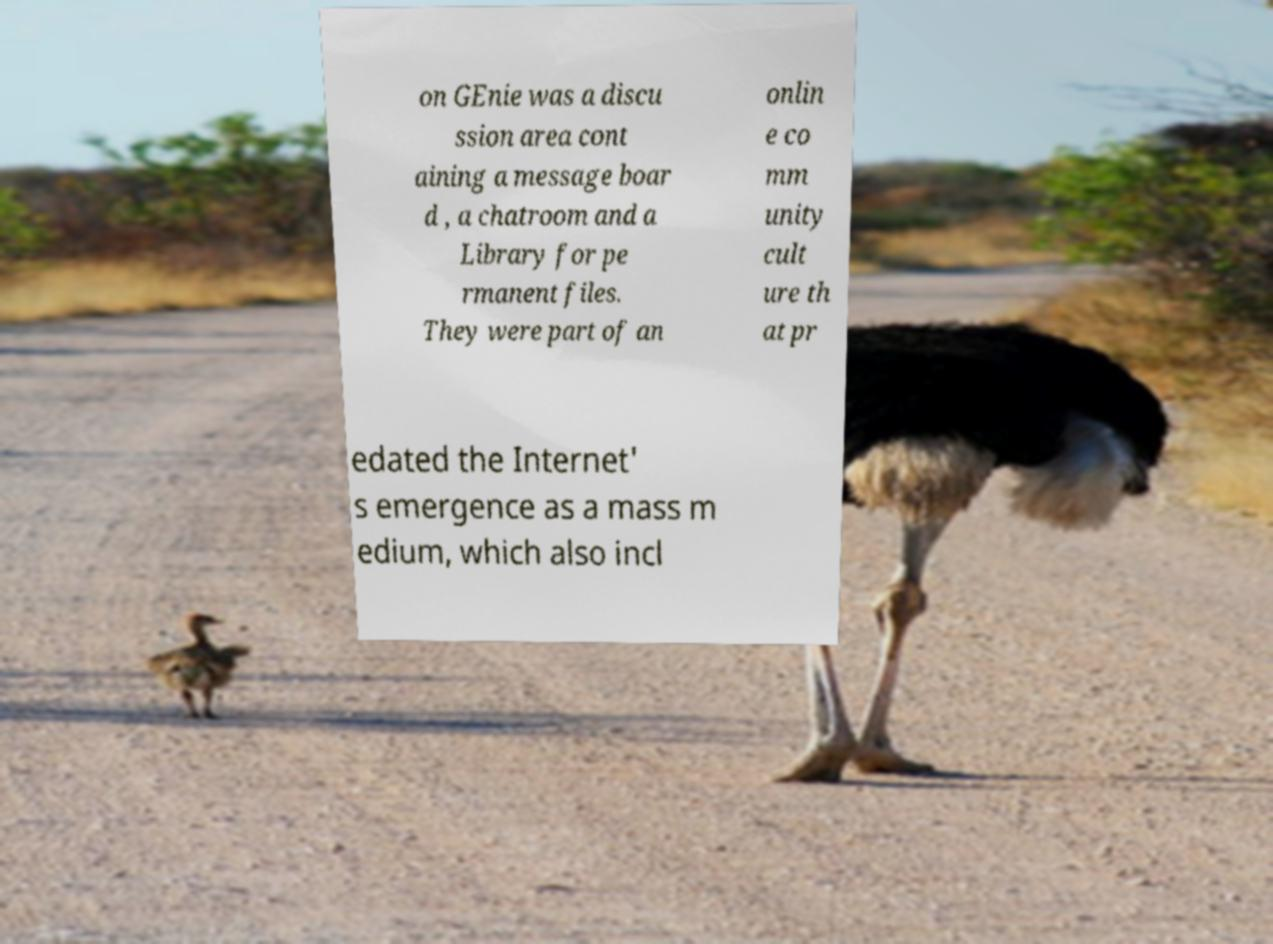There's text embedded in this image that I need extracted. Can you transcribe it verbatim? on GEnie was a discu ssion area cont aining a message boar d , a chatroom and a Library for pe rmanent files. They were part of an onlin e co mm unity cult ure th at pr edated the Internet' s emergence as a mass m edium, which also incl 